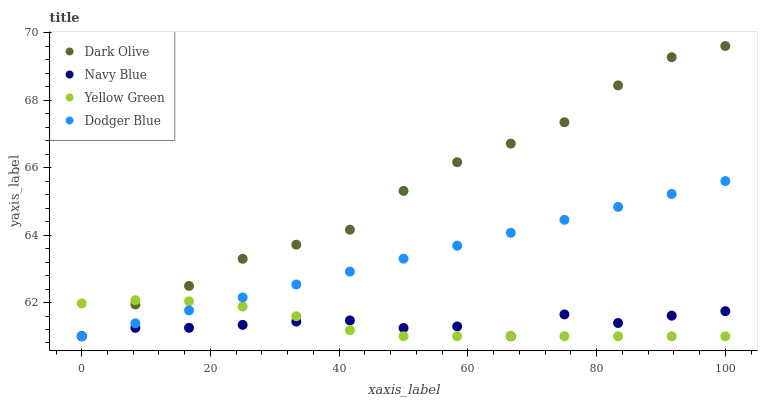Does Yellow Green have the minimum area under the curve?
Answer yes or no. Yes. Does Dark Olive have the maximum area under the curve?
Answer yes or no. Yes. Does Dodger Blue have the minimum area under the curve?
Answer yes or no. No. Does Dodger Blue have the maximum area under the curve?
Answer yes or no. No. Is Dodger Blue the smoothest?
Answer yes or no. Yes. Is Navy Blue the roughest?
Answer yes or no. Yes. Is Dark Olive the smoothest?
Answer yes or no. No. Is Dark Olive the roughest?
Answer yes or no. No. Does Navy Blue have the lowest value?
Answer yes or no. Yes. Does Dark Olive have the highest value?
Answer yes or no. Yes. Does Dodger Blue have the highest value?
Answer yes or no. No. Does Dodger Blue intersect Navy Blue?
Answer yes or no. Yes. Is Dodger Blue less than Navy Blue?
Answer yes or no. No. Is Dodger Blue greater than Navy Blue?
Answer yes or no. No. 